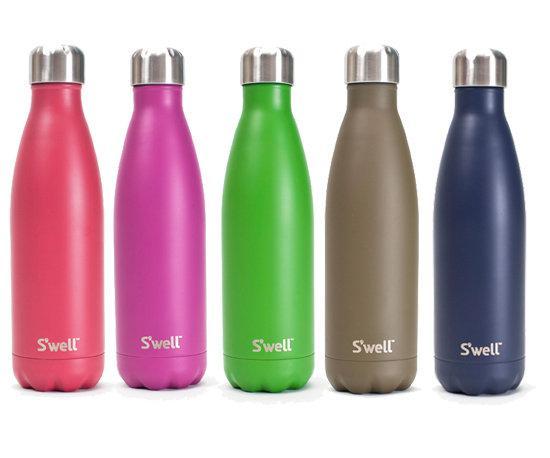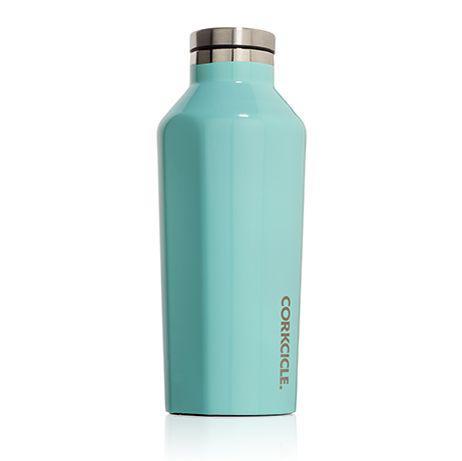The first image is the image on the left, the second image is the image on the right. Considering the images on both sides, is "In one image, five bottles with chrome caps and dimpled bottom sections are the same design, but in different colors" valid? Answer yes or no. Yes. The first image is the image on the left, the second image is the image on the right. Evaluate the accuracy of this statement regarding the images: "The bottles in one of the images are sitting outside.". Is it true? Answer yes or no. No. 